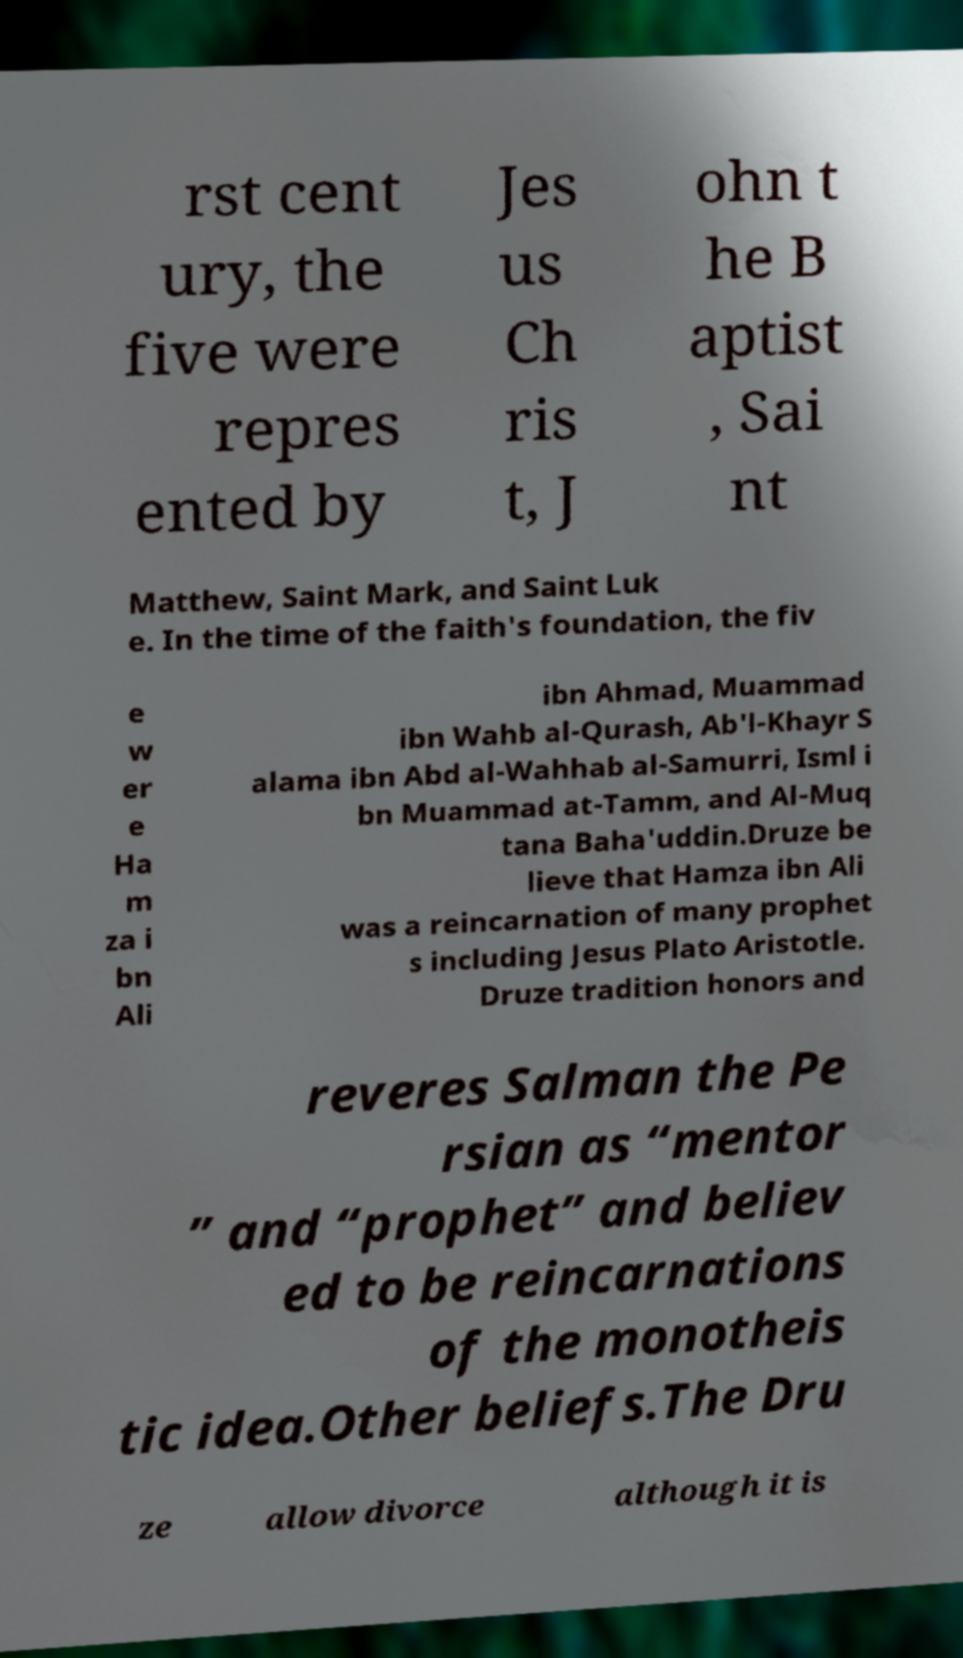Can you accurately transcribe the text from the provided image for me? rst cent ury, the five were repres ented by Jes us Ch ris t, J ohn t he B aptist , Sai nt Matthew, Saint Mark, and Saint Luk e. In the time of the faith's foundation, the fiv e w er e Ha m za i bn Ali ibn Ahmad, Muammad ibn Wahb al-Qurash, Ab'l-Khayr S alama ibn Abd al-Wahhab al-Samurri, Isml i bn Muammad at-Tamm, and Al-Muq tana Baha'uddin.Druze be lieve that Hamza ibn Ali was a reincarnation of many prophet s including Jesus Plato Aristotle. Druze tradition honors and reveres Salman the Pe rsian as “mentor ” and “prophet” and believ ed to be reincarnations of the monotheis tic idea.Other beliefs.The Dru ze allow divorce although it is 